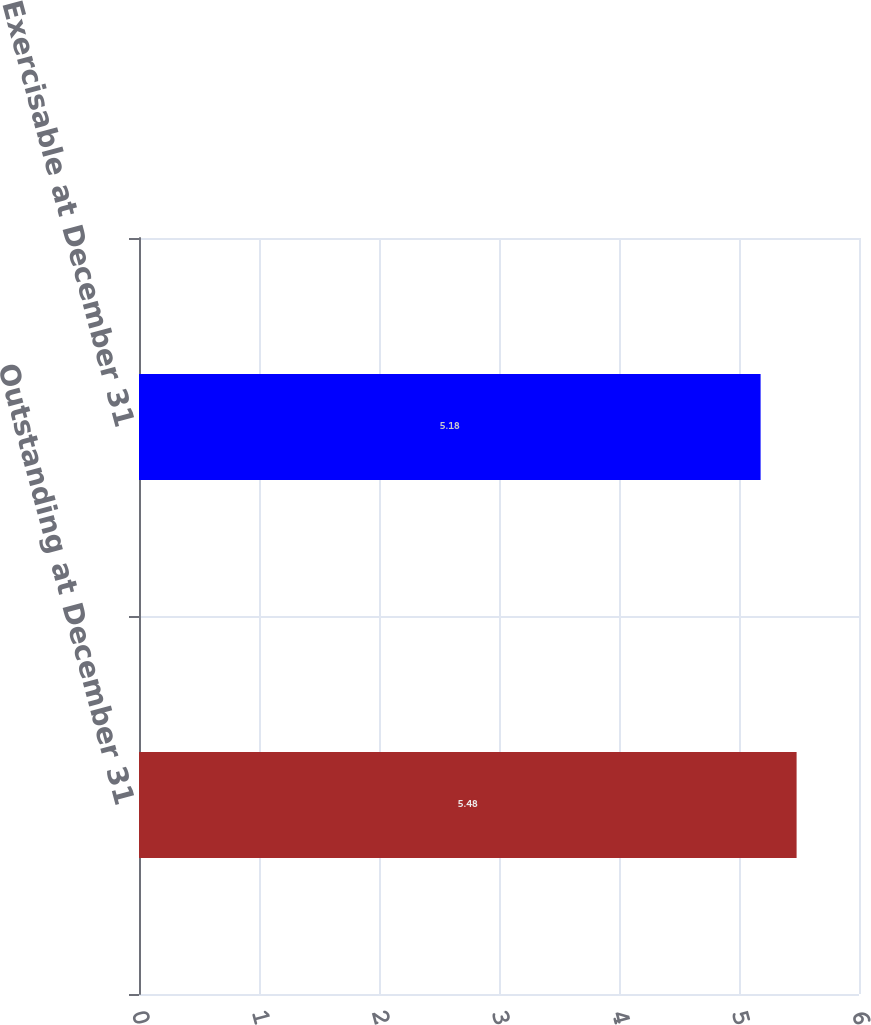Convert chart to OTSL. <chart><loc_0><loc_0><loc_500><loc_500><bar_chart><fcel>Outstanding at December 31<fcel>Exercisable at December 31<nl><fcel>5.48<fcel>5.18<nl></chart> 